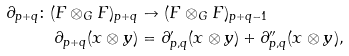<formula> <loc_0><loc_0><loc_500><loc_500>\partial _ { p + q } \colon ( F \otimes _ { G } F ) _ { p + q } & \to ( F \otimes _ { G } F ) _ { p + q - 1 } \\ \partial _ { p + q } ( x \otimes y ) & = \partial _ { p , q } ^ { \prime } ( x \otimes y ) + \partial _ { p , q } ^ { \prime \prime } ( x \otimes y ) ,</formula> 